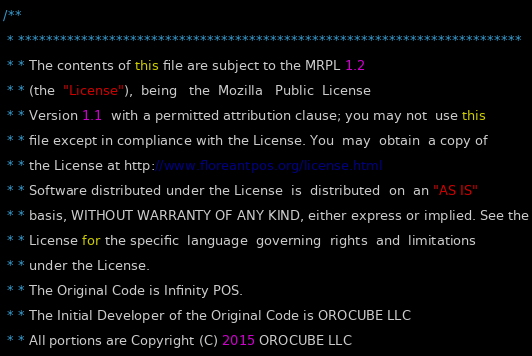<code> <loc_0><loc_0><loc_500><loc_500><_Java_>/**
 * ************************************************************************
 * * The contents of this file are subject to the MRPL 1.2
 * * (the  "License"),  being   the  Mozilla   Public  License
 * * Version 1.1  with a permitted attribution clause; you may not  use this
 * * file except in compliance with the License. You  may  obtain  a copy of
 * * the License at http://www.floreantpos.org/license.html
 * * Software distributed under the License  is  distributed  on  an "AS IS"
 * * basis, WITHOUT WARRANTY OF ANY KIND, either express or implied. See the
 * * License for the specific  language  governing  rights  and  limitations
 * * under the License.
 * * The Original Code is Infinity POS.
 * * The Initial Developer of the Original Code is OROCUBE LLC
 * * All portions are Copyright (C) 2015 OROCUBE LLC</code> 